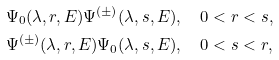<formula> <loc_0><loc_0><loc_500><loc_500>& \Psi _ { 0 } ( \lambda , r , E ) \Psi ^ { ( \pm ) } ( \lambda , s , E ) , \quad 0 < r < s , \\ & \Psi ^ { ( \pm ) } ( \lambda , r , E ) \Psi _ { 0 } ( \lambda , s , E ) , \quad 0 < s < r ,</formula> 